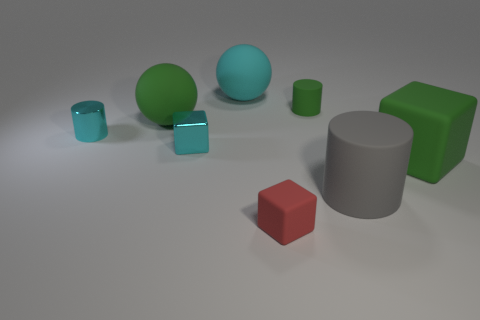Subtract all tiny cyan cylinders. How many cylinders are left? 2 Add 1 tiny yellow matte objects. How many objects exist? 9 Subtract all blocks. How many objects are left? 5 Subtract 1 spheres. How many spheres are left? 1 Subtract all green balls. How many balls are left? 1 Subtract all blue balls. Subtract all yellow cylinders. How many balls are left? 2 Subtract all red blocks. How many green cylinders are left? 1 Subtract all cyan things. Subtract all gray cylinders. How many objects are left? 4 Add 8 tiny red things. How many tiny red things are left? 9 Add 6 red rubber blocks. How many red rubber blocks exist? 7 